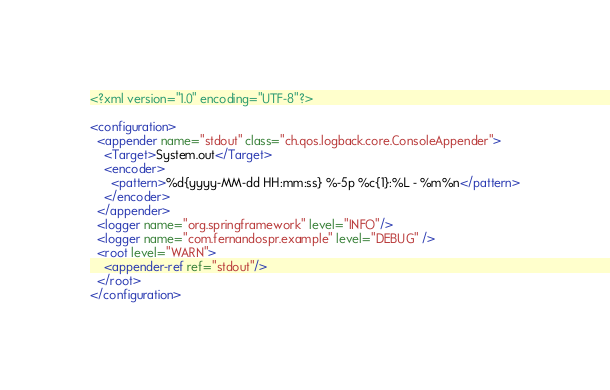Convert code to text. <code><loc_0><loc_0><loc_500><loc_500><_XML_><?xml version="1.0" encoding="UTF-8"?>

<configuration>
  <appender name="stdout" class="ch.qos.logback.core.ConsoleAppender">
    <Target>System.out</Target>
    <encoder>
      <pattern>%d{yyyy-MM-dd HH:mm:ss} %-5p %c{1}:%L - %m%n</pattern>
    </encoder>
  </appender>
  <logger name="org.springframework" level="INFO"/>
  <logger name="com.fernandospr.example" level="DEBUG" />
  <root level="WARN">
    <appender-ref ref="stdout"/>
  </root>
</configuration></code> 